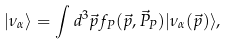<formula> <loc_0><loc_0><loc_500><loc_500>| \nu _ { \alpha } \rangle = \int d ^ { 3 } \vec { p } f _ { P } ( \vec { p } , \vec { P } _ { P } ) | \nu _ { \alpha } ( \vec { p } ) \rangle ,</formula> 